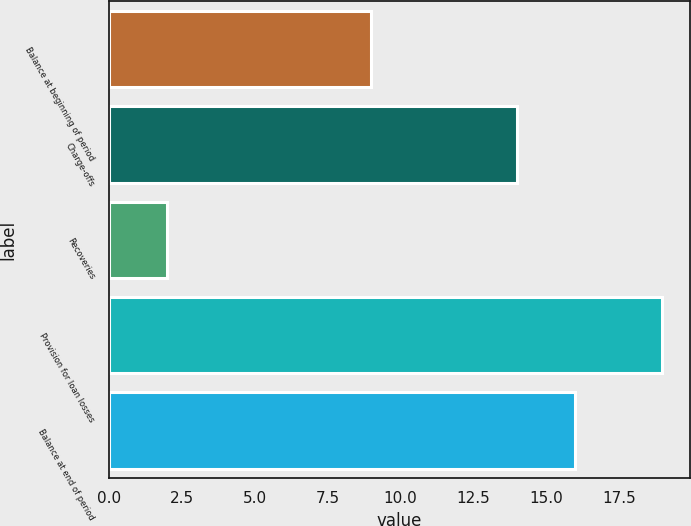<chart> <loc_0><loc_0><loc_500><loc_500><bar_chart><fcel>Balance at beginning of period<fcel>Charge-offs<fcel>Recoveries<fcel>Provision for loan losses<fcel>Balance at end of period<nl><fcel>9<fcel>14<fcel>2<fcel>19<fcel>16<nl></chart> 